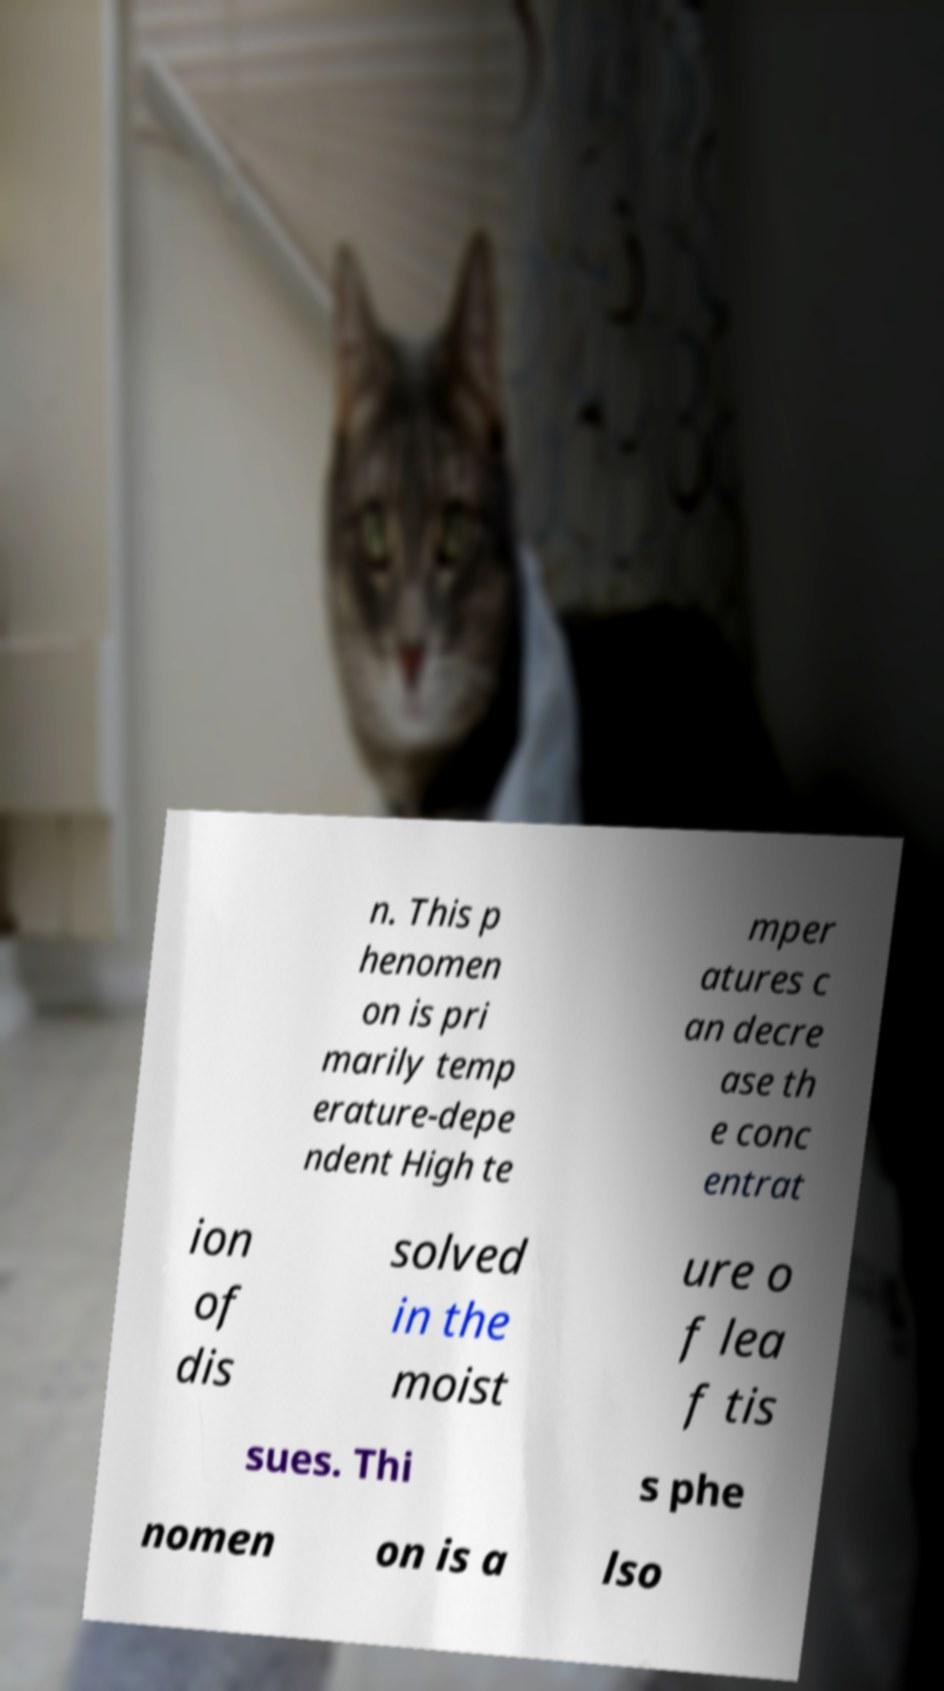What messages or text are displayed in this image? I need them in a readable, typed format. n. This p henomen on is pri marily temp erature-depe ndent High te mper atures c an decre ase th e conc entrat ion of dis solved in the moist ure o f lea f tis sues. Thi s phe nomen on is a lso 